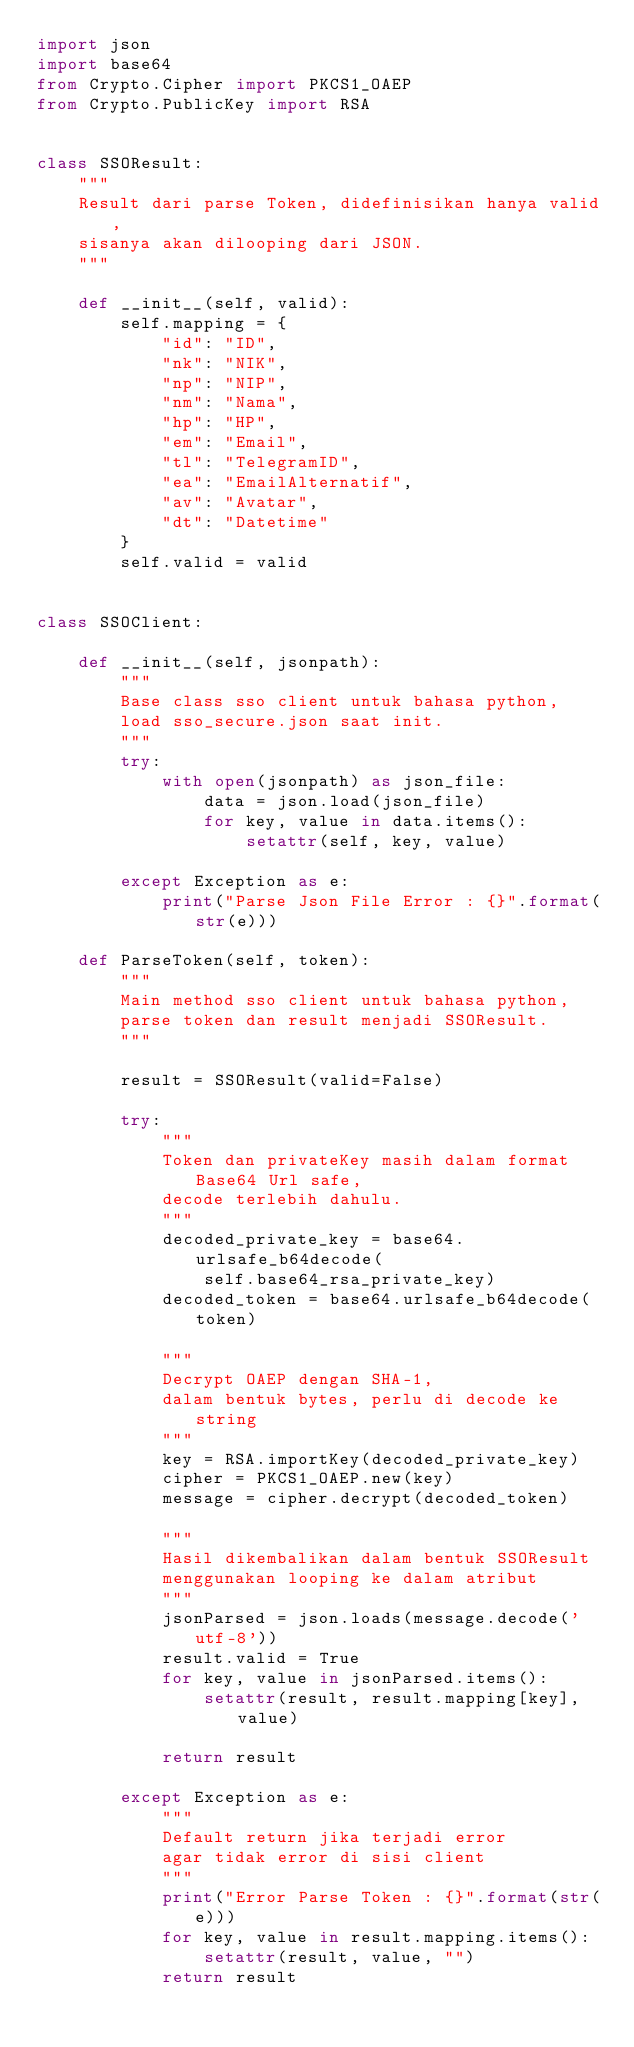Convert code to text. <code><loc_0><loc_0><loc_500><loc_500><_Python_>import json
import base64
from Crypto.Cipher import PKCS1_OAEP
from Crypto.PublicKey import RSA


class SSOResult:
    """
    Result dari parse Token, didefinisikan hanya valid,
    sisanya akan dilooping dari JSON.
    """

    def __init__(self, valid):
        self.mapping = {
            "id": "ID",
            "nk": "NIK",
            "np": "NIP",
            "nm": "Nama",
            "hp": "HP",
            "em": "Email",
            "tl": "TelegramID",
            "ea": "EmailAlternatif",
            "av": "Avatar",
            "dt": "Datetime"
        }
        self.valid = valid


class SSOClient:

    def __init__(self, jsonpath):
        """
        Base class sso client untuk bahasa python,
        load sso_secure.json saat init.
        """
        try:
            with open(jsonpath) as json_file:
                data = json.load(json_file)
                for key, value in data.items():
                    setattr(self, key, value)

        except Exception as e:
            print("Parse Json File Error : {}".format(str(e)))

    def ParseToken(self, token):
        """
        Main method sso client untuk bahasa python,
        parse token dan result menjadi SSOResult.
        """

        result = SSOResult(valid=False)

        try:
            """
            Token dan privateKey masih dalam format Base64 Url safe,
            decode terlebih dahulu.
            """
            decoded_private_key = base64.urlsafe_b64decode(
                self.base64_rsa_private_key)
            decoded_token = base64.urlsafe_b64decode(token)

            """
            Decrypt OAEP dengan SHA-1,
            dalam bentuk bytes, perlu di decode ke string
            """
            key = RSA.importKey(decoded_private_key)
            cipher = PKCS1_OAEP.new(key)
            message = cipher.decrypt(decoded_token)

            """
            Hasil dikembalikan dalam bentuk SSOResult
            menggunakan looping ke dalam atribut
            """
            jsonParsed = json.loads(message.decode('utf-8'))
            result.valid = True
            for key, value in jsonParsed.items():
                setattr(result, result.mapping[key], value)

            return result

        except Exception as e:
            """
            Default return jika terjadi error
            agar tidak error di sisi client
            """
            print("Error Parse Token : {}".format(str(e)))
            for key, value in result.mapping.items():
                setattr(result, value, "")
            return result
</code> 